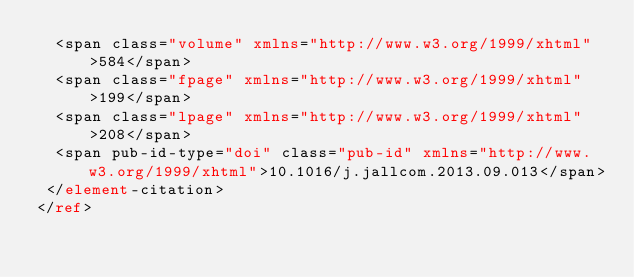<code> <loc_0><loc_0><loc_500><loc_500><_XML_>  <span class="volume" xmlns="http://www.w3.org/1999/xhtml">584</span>
  <span class="fpage" xmlns="http://www.w3.org/1999/xhtml">199</span>
  <span class="lpage" xmlns="http://www.w3.org/1999/xhtml">208</span>
  <span pub-id-type="doi" class="pub-id" xmlns="http://www.w3.org/1999/xhtml">10.1016/j.jallcom.2013.09.013</span>
 </element-citation>
</ref>
</code> 